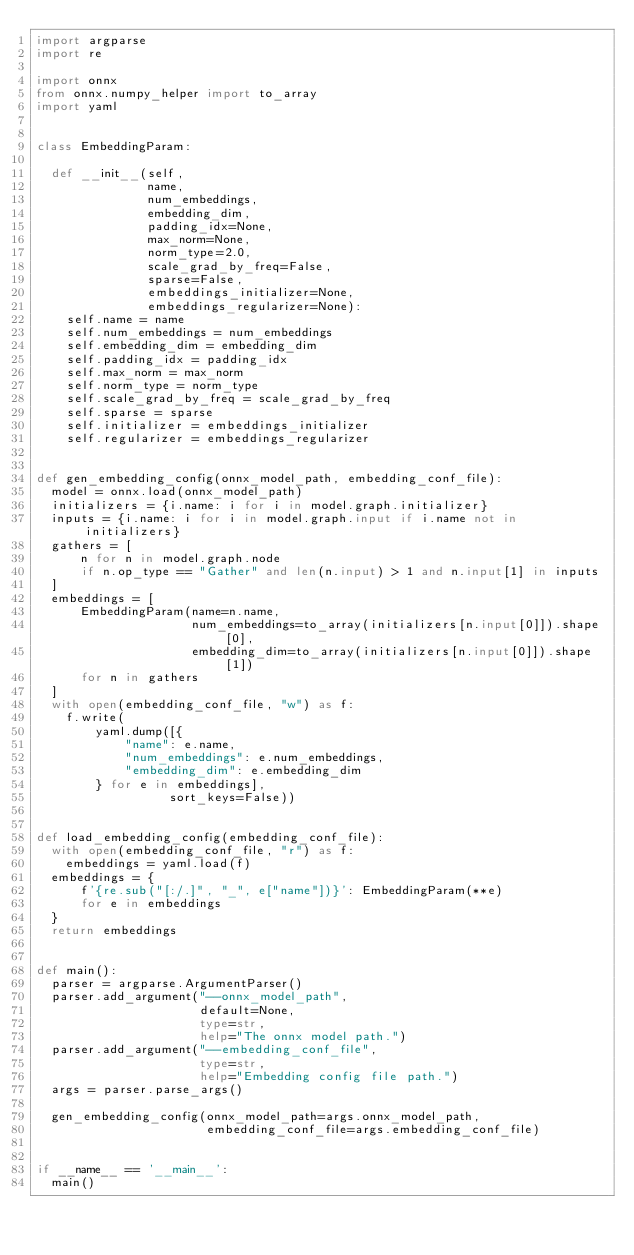<code> <loc_0><loc_0><loc_500><loc_500><_Python_>import argparse
import re

import onnx
from onnx.numpy_helper import to_array
import yaml


class EmbeddingParam:

  def __init__(self,
               name,
               num_embeddings,
               embedding_dim,
               padding_idx=None,
               max_norm=None,
               norm_type=2.0,
               scale_grad_by_freq=False,
               sparse=False,
               embeddings_initializer=None,
               embeddings_regularizer=None):
    self.name = name
    self.num_embeddings = num_embeddings
    self.embedding_dim = embedding_dim
    self.padding_idx = padding_idx
    self.max_norm = max_norm
    self.norm_type = norm_type
    self.scale_grad_by_freq = scale_grad_by_freq
    self.sparse = sparse
    self.initializer = embeddings_initializer
    self.regularizer = embeddings_regularizer


def gen_embedding_config(onnx_model_path, embedding_conf_file):
  model = onnx.load(onnx_model_path)
  initializers = {i.name: i for i in model.graph.initializer}
  inputs = {i.name: i for i in model.graph.input if i.name not in initializers}
  gathers = [
      n for n in model.graph.node
      if n.op_type == "Gather" and len(n.input) > 1 and n.input[1] in inputs
  ]
  embeddings = [
      EmbeddingParam(name=n.name,
                     num_embeddings=to_array(initializers[n.input[0]]).shape[0],
                     embedding_dim=to_array(initializers[n.input[0]]).shape[1])
      for n in gathers
  ]
  with open(embedding_conf_file, "w") as f:
    f.write(
        yaml.dump([{
            "name": e.name,
            "num_embeddings": e.num_embeddings,
            "embedding_dim": e.embedding_dim
        } for e in embeddings],
                  sort_keys=False))


def load_embedding_config(embedding_conf_file):
  with open(embedding_conf_file, "r") as f:
    embeddings = yaml.load(f)
  embeddings = {
      f'{re.sub("[:/.]", "_", e["name"])}': EmbeddingParam(**e)
      for e in embeddings
  }
  return embeddings


def main():
  parser = argparse.ArgumentParser()
  parser.add_argument("--onnx_model_path",
                      default=None,
                      type=str,
                      help="The onnx model path.")
  parser.add_argument("--embedding_conf_file",
                      type=str,
                      help="Embedding config file path.")
  args = parser.parse_args()

  gen_embedding_config(onnx_model_path=args.onnx_model_path,
                       embedding_conf_file=args.embedding_conf_file)


if __name__ == '__main__':
  main()
</code> 